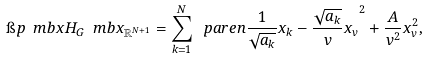Convert formula to latex. <formula><loc_0><loc_0><loc_500><loc_500>\i p { \ m b { x } } { H _ { G } \ m b { x } } _ { \mathbb { R } ^ { N + 1 } } = \sum _ { k = 1 } ^ { N } \ p a r e n { \frac { 1 } { \sqrt { a _ { k } } } x _ { k } - \frac { \sqrt { a _ { k } } } { v } x _ { v } } ^ { 2 } + \frac { A } { v ^ { 2 } } x _ { v } ^ { 2 } ,</formula> 